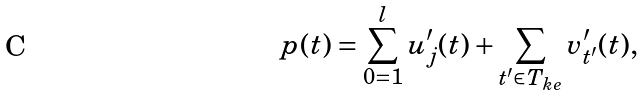<formula> <loc_0><loc_0><loc_500><loc_500>p ( t ) = \sum _ { 0 = 1 } ^ { l } u ^ { \prime } _ { j } ( t ) + \sum _ { t ^ { \prime } \in T _ { k e } } v ^ { \prime } _ { t ^ { \prime } } ( t ) ,</formula> 